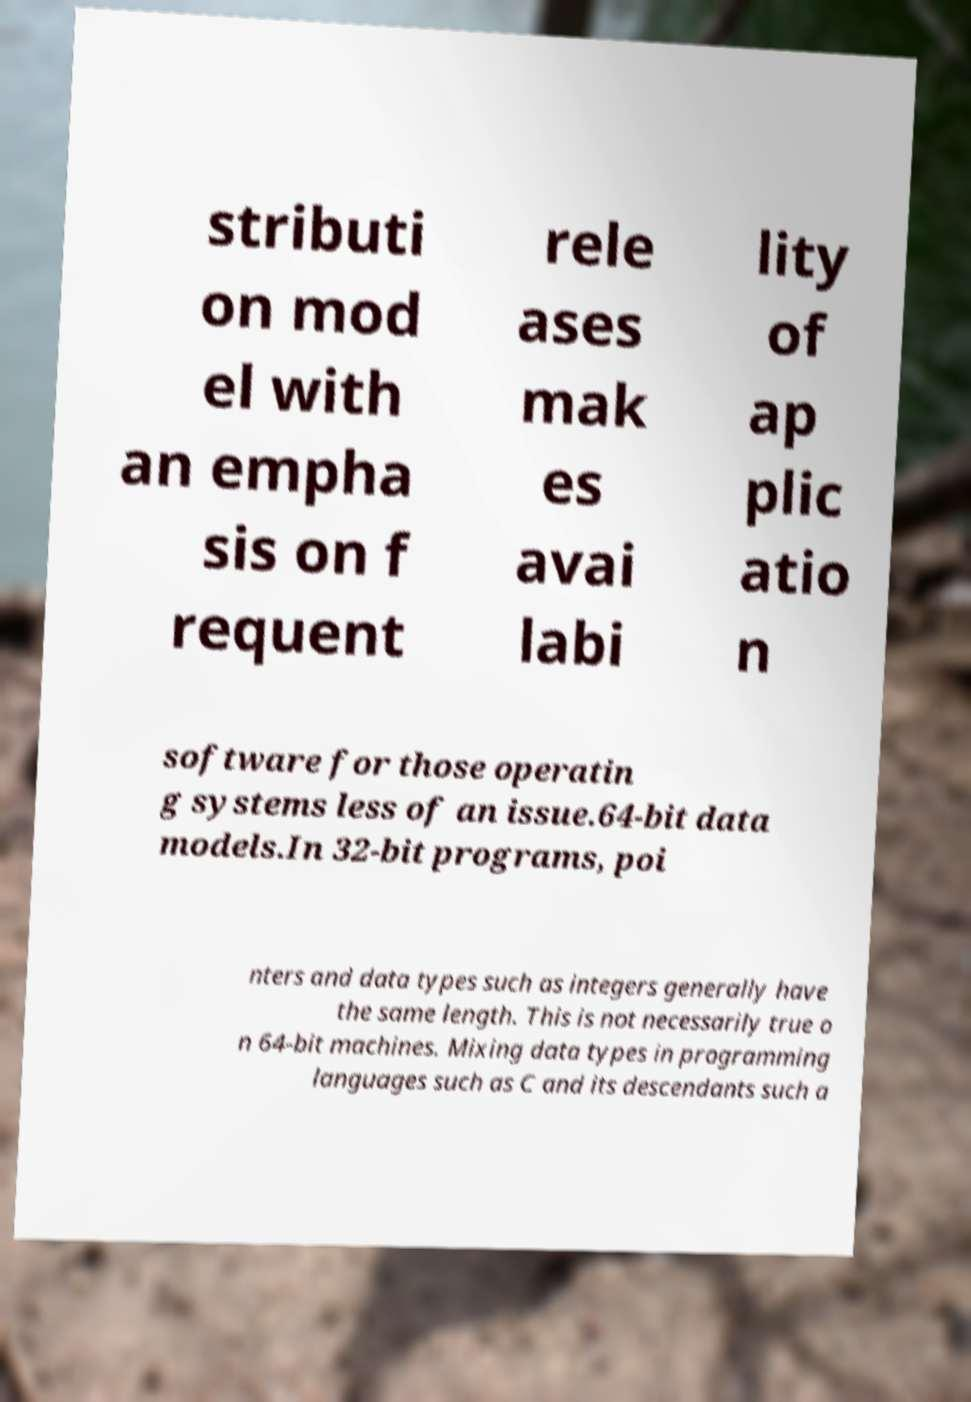What messages or text are displayed in this image? I need them in a readable, typed format. stributi on mod el with an empha sis on f requent rele ases mak es avai labi lity of ap plic atio n software for those operatin g systems less of an issue.64-bit data models.In 32-bit programs, poi nters and data types such as integers generally have the same length. This is not necessarily true o n 64-bit machines. Mixing data types in programming languages such as C and its descendants such a 